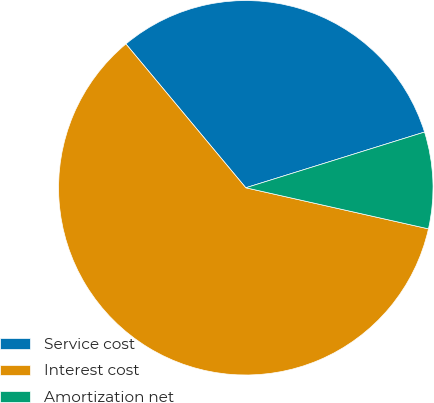<chart> <loc_0><loc_0><loc_500><loc_500><pie_chart><fcel>Service cost<fcel>Interest cost<fcel>Amortization net<nl><fcel>31.25%<fcel>60.42%<fcel>8.33%<nl></chart> 